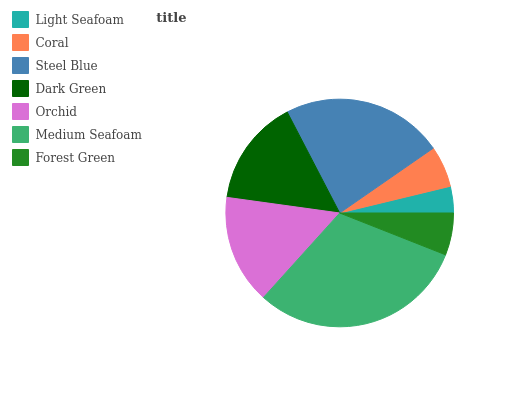Is Light Seafoam the minimum?
Answer yes or no. Yes. Is Medium Seafoam the maximum?
Answer yes or no. Yes. Is Coral the minimum?
Answer yes or no. No. Is Coral the maximum?
Answer yes or no. No. Is Coral greater than Light Seafoam?
Answer yes or no. Yes. Is Light Seafoam less than Coral?
Answer yes or no. Yes. Is Light Seafoam greater than Coral?
Answer yes or no. No. Is Coral less than Light Seafoam?
Answer yes or no. No. Is Dark Green the high median?
Answer yes or no. Yes. Is Dark Green the low median?
Answer yes or no. Yes. Is Forest Green the high median?
Answer yes or no. No. Is Forest Green the low median?
Answer yes or no. No. 